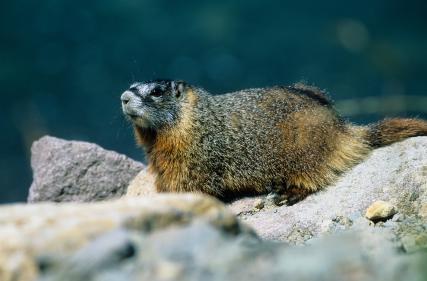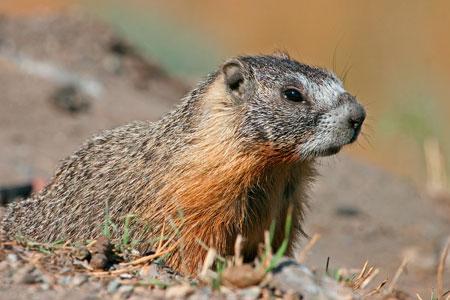The first image is the image on the left, the second image is the image on the right. Analyze the images presented: Is the assertion "The rodent in the right image is looking towards the right." valid? Answer yes or no. Yes. The first image is the image on the left, the second image is the image on the right. For the images displayed, is the sentence "Two marmots are facing in opposite directions" factually correct? Answer yes or no. Yes. The first image is the image on the left, the second image is the image on the right. Examine the images to the left and right. Is the description "One of the animals is facing towards the left." accurate? Answer yes or no. Yes. 